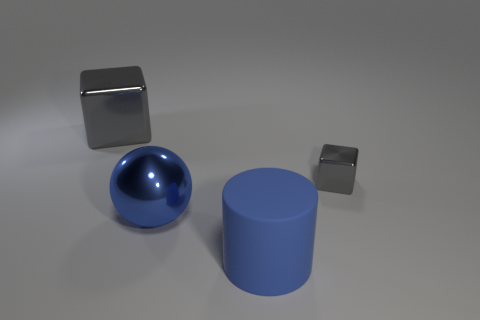Add 3 big cubes. How many objects exist? 7 Subtract all cylinders. How many objects are left? 3 Subtract all small gray shiny cubes. Subtract all big blue rubber things. How many objects are left? 2 Add 3 large blue objects. How many large blue objects are left? 5 Add 2 small green cylinders. How many small green cylinders exist? 2 Subtract 0 cyan cubes. How many objects are left? 4 